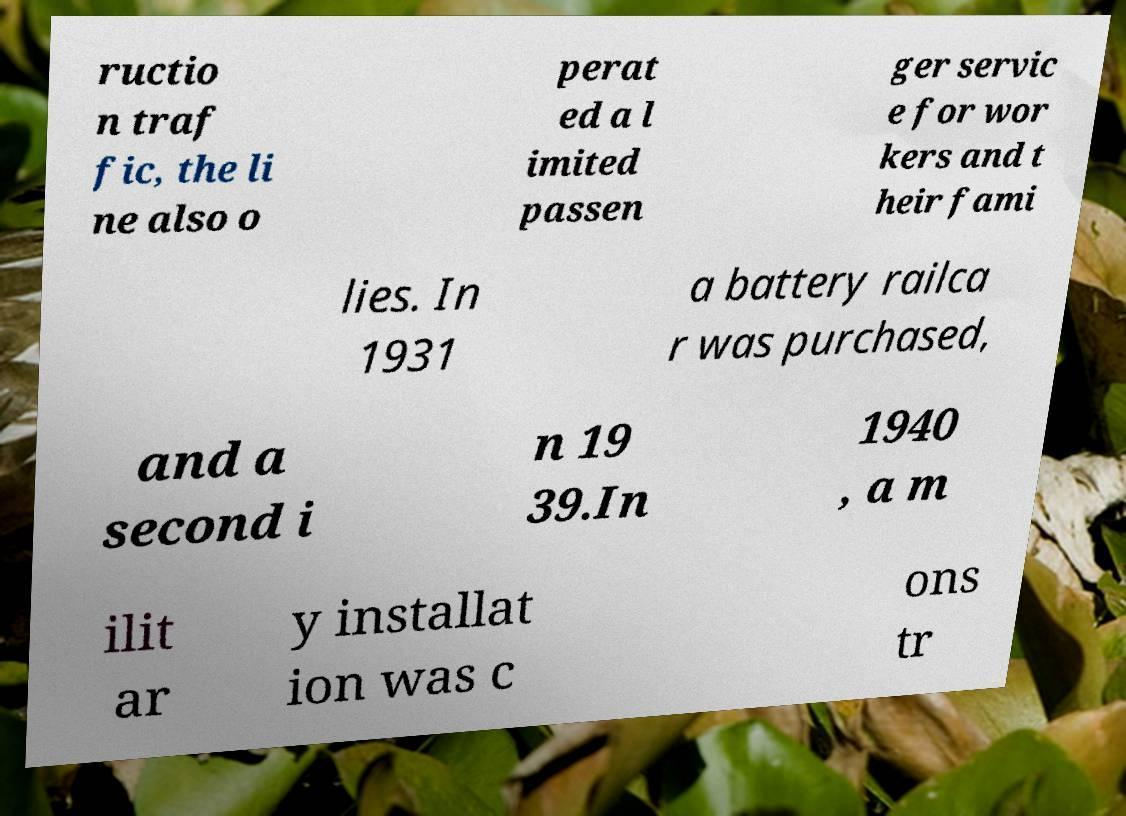Could you assist in decoding the text presented in this image and type it out clearly? ructio n traf fic, the li ne also o perat ed a l imited passen ger servic e for wor kers and t heir fami lies. In 1931 a battery railca r was purchased, and a second i n 19 39.In 1940 , a m ilit ar y installat ion was c ons tr 